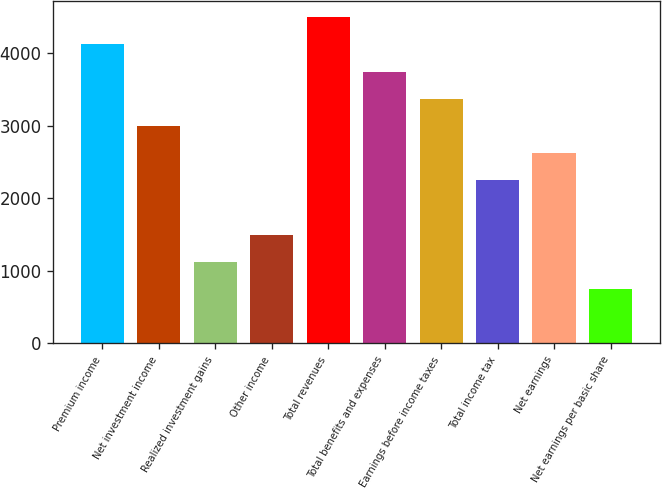Convert chart to OTSL. <chart><loc_0><loc_0><loc_500><loc_500><bar_chart><fcel>Premium income<fcel>Net investment income<fcel>Realized investment gains<fcel>Other income<fcel>Total revenues<fcel>Total benefits and expenses<fcel>Earnings before income taxes<fcel>Total income tax<fcel>Net earnings<fcel>Net earnings per basic share<nl><fcel>4126.06<fcel>3000.82<fcel>1125.42<fcel>1500.5<fcel>4501.14<fcel>3750.98<fcel>3375.9<fcel>2250.66<fcel>2625.74<fcel>750.34<nl></chart> 